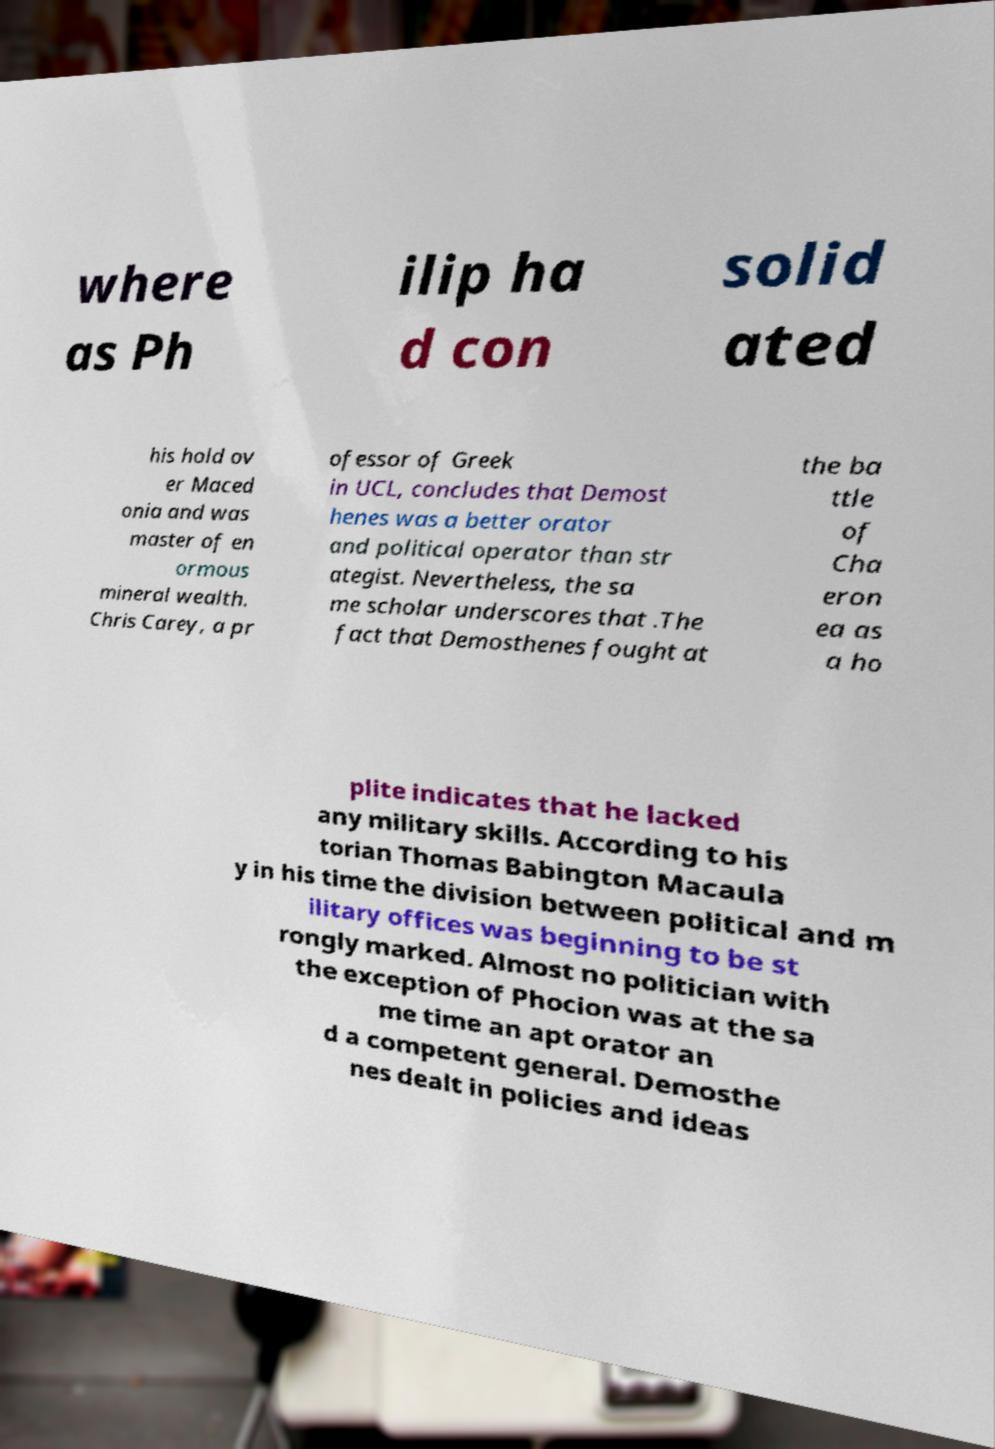What messages or text are displayed in this image? I need them in a readable, typed format. where as Ph ilip ha d con solid ated his hold ov er Maced onia and was master of en ormous mineral wealth. Chris Carey, a pr ofessor of Greek in UCL, concludes that Demost henes was a better orator and political operator than str ategist. Nevertheless, the sa me scholar underscores that .The fact that Demosthenes fought at the ba ttle of Cha eron ea as a ho plite indicates that he lacked any military skills. According to his torian Thomas Babington Macaula y in his time the division between political and m ilitary offices was beginning to be st rongly marked. Almost no politician with the exception of Phocion was at the sa me time an apt orator an d a competent general. Demosthe nes dealt in policies and ideas 